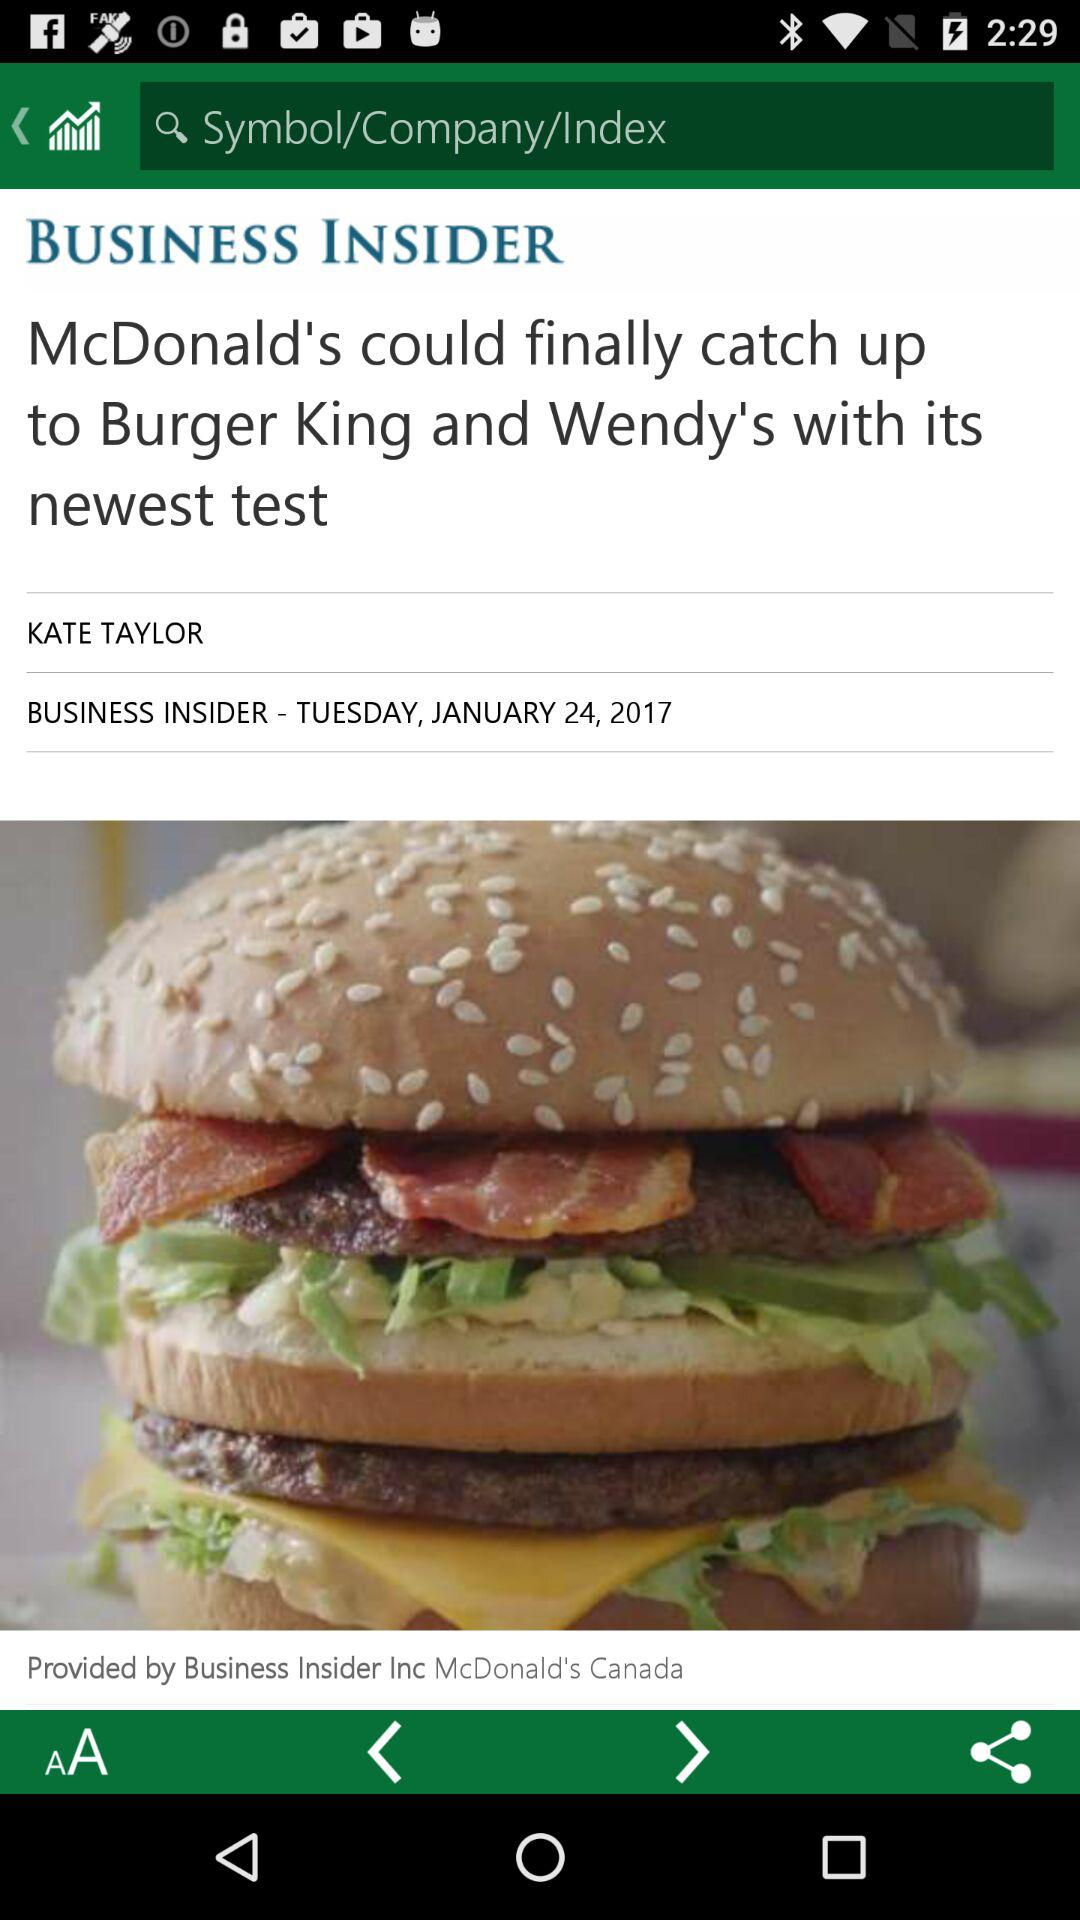What is the publication date? The publication date is Tuesday, January 24, 2017. 